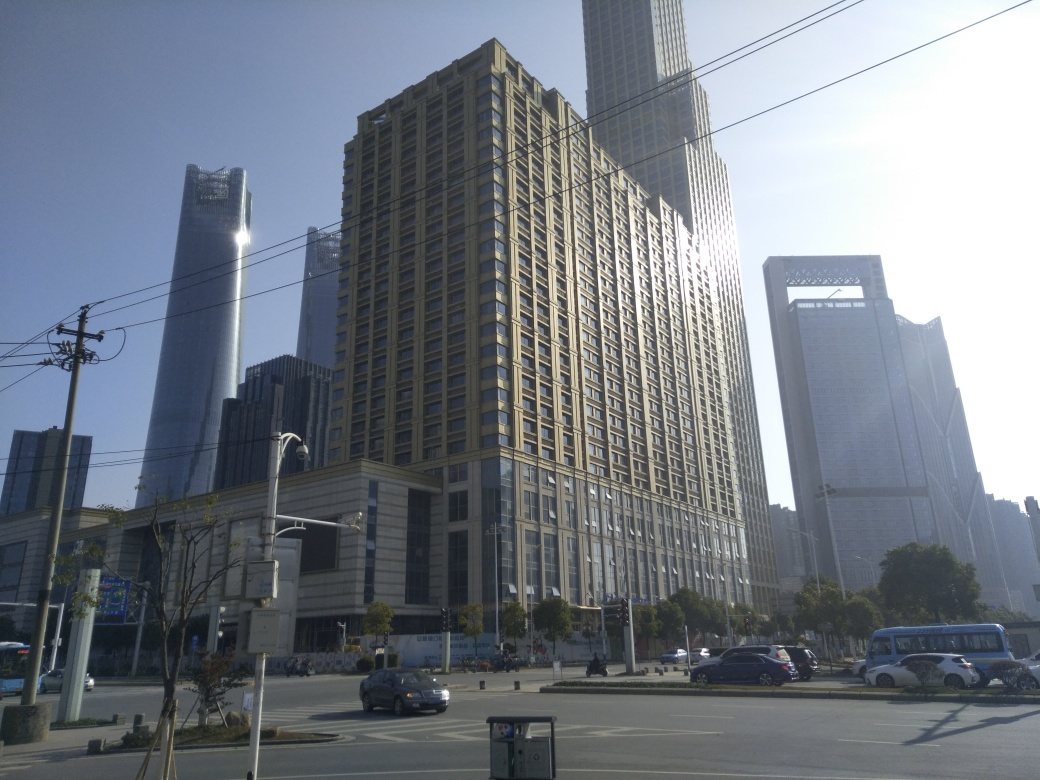Can you guess the time of day this picture was taken? Given the long shadows cast by the buildings and the angle of the sunlight, it appears that this picture was taken in the late afternoon. 